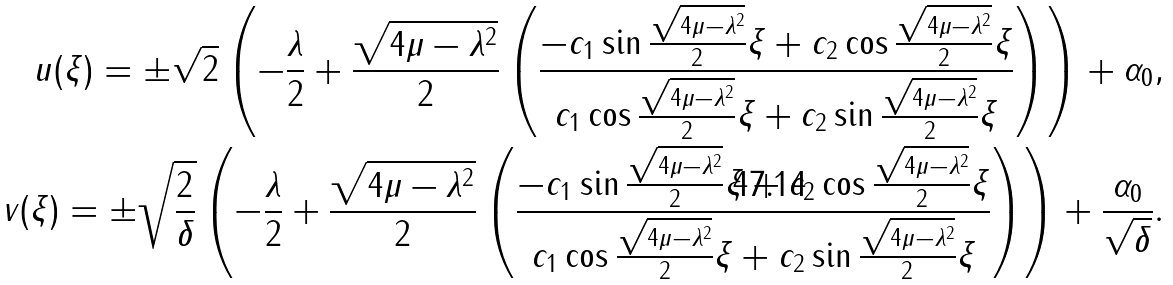<formula> <loc_0><loc_0><loc_500><loc_500>u ( \xi ) = \pm \sqrt { 2 } \left ( - \frac { \lambda } { 2 } + \frac { \sqrt { 4 \mu - \lambda ^ { 2 } } } { 2 } \left ( \frac { - c _ { 1 } \sin \frac { \sqrt { 4 \mu - \lambda ^ { 2 } } } { 2 } \xi + c _ { 2 } \cos \frac { \sqrt { 4 \mu - \lambda ^ { 2 } } } { 2 } \xi } { c _ { 1 } \cos \frac { \sqrt { 4 \mu - \lambda ^ { 2 } } } { 2 } \xi + c _ { 2 } \sin \frac { \sqrt { 4 \mu - \lambda ^ { 2 } } } { 2 } \xi } \right ) \right ) + \alpha _ { 0 } , \\ \quad v ( \xi ) = \pm \sqrt { \frac { 2 } { \delta } } \left ( - \frac { \lambda } { 2 } + \frac { \sqrt { 4 \mu - \lambda ^ { 2 } } } { 2 } \left ( \frac { - c _ { 1 } \sin \frac { \sqrt { 4 \mu - \lambda ^ { 2 } } } { 2 } \xi + c _ { 2 } \cos \frac { \sqrt { 4 \mu - \lambda ^ { 2 } } } { 2 } \xi } { c _ { 1 } \cos \frac { \sqrt { 4 \mu - \lambda ^ { 2 } } } { 2 } \xi + c _ { 2 } \sin \frac { \sqrt { 4 \mu - \lambda ^ { 2 } } } { 2 } \xi } \right ) \right ) + \frac { \alpha _ { 0 } } { \sqrt { \delta } } .</formula> 